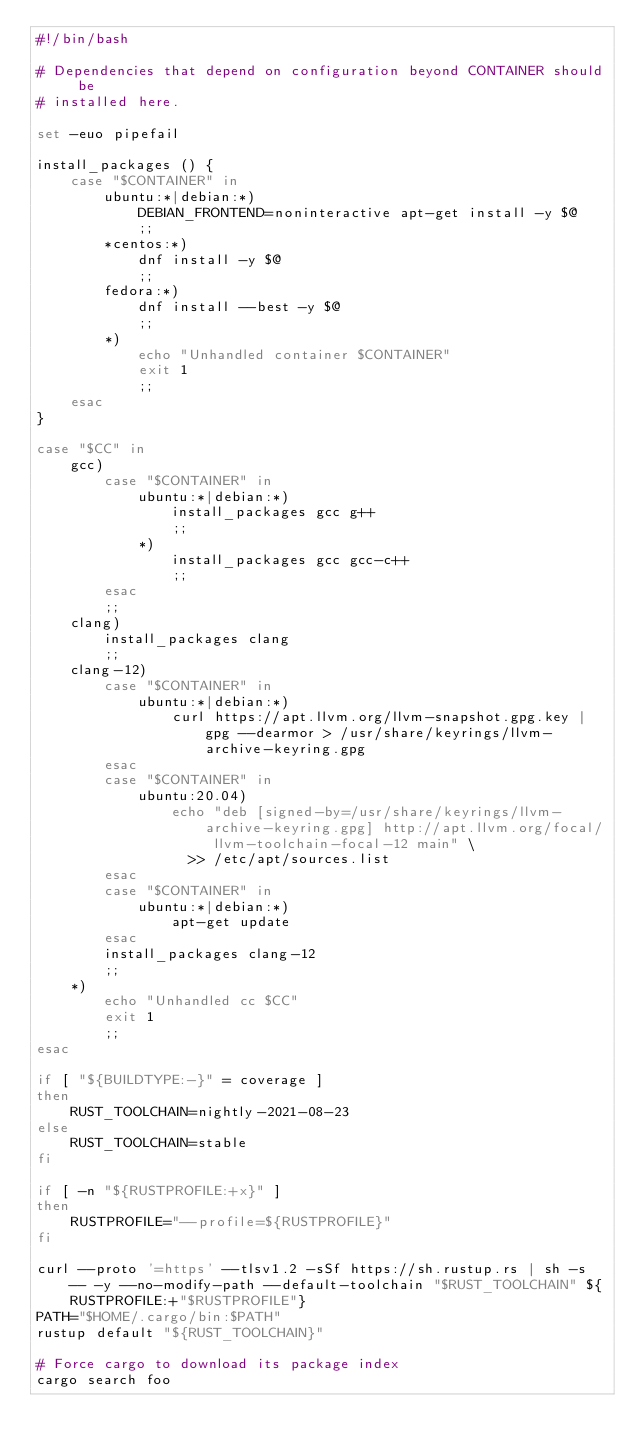<code> <loc_0><loc_0><loc_500><loc_500><_Bash_>#!/bin/bash

# Dependencies that depend on configuration beyond CONTAINER should be
# installed here.

set -euo pipefail

install_packages () {
    case "$CONTAINER" in
        ubuntu:*|debian:*)
            DEBIAN_FRONTEND=noninteractive apt-get install -y $@
            ;;
        *centos:*)
            dnf install -y $@
            ;;
        fedora:*)
            dnf install --best -y $@
            ;;
        *)
            echo "Unhandled container $CONTAINER"
            exit 1
            ;;
    esac
}

case "$CC" in
    gcc)
        case "$CONTAINER" in
            ubuntu:*|debian:*)
                install_packages gcc g++
                ;;
            *)
                install_packages gcc gcc-c++
                ;;
        esac
        ;;
    clang)
        install_packages clang
        ;;
    clang-12)
        case "$CONTAINER" in
            ubuntu:*|debian:*)
                curl https://apt.llvm.org/llvm-snapshot.gpg.key | gpg --dearmor > /usr/share/keyrings/llvm-archive-keyring.gpg
        esac
        case "$CONTAINER" in
            ubuntu:20.04)
                echo "deb [signed-by=/usr/share/keyrings/llvm-archive-keyring.gpg] http://apt.llvm.org/focal/ llvm-toolchain-focal-12 main" \
                  >> /etc/apt/sources.list
        esac
        case "$CONTAINER" in
            ubuntu:*|debian:*)
                apt-get update
        esac
        install_packages clang-12
        ;;
    *)
        echo "Unhandled cc $CC"
        exit 1
        ;;
esac

if [ "${BUILDTYPE:-}" = coverage ]
then
    RUST_TOOLCHAIN=nightly-2021-08-23
else
    RUST_TOOLCHAIN=stable
fi

if [ -n "${RUSTPROFILE:+x}" ]
then
    RUSTPROFILE="--profile=${RUSTPROFILE}"
fi

curl --proto '=https' --tlsv1.2 -sSf https://sh.rustup.rs | sh -s -- -y --no-modify-path --default-toolchain "$RUST_TOOLCHAIN" ${RUSTPROFILE:+"$RUSTPROFILE"}
PATH="$HOME/.cargo/bin:$PATH"
rustup default "${RUST_TOOLCHAIN}"

# Force cargo to download its package index
cargo search foo
</code> 